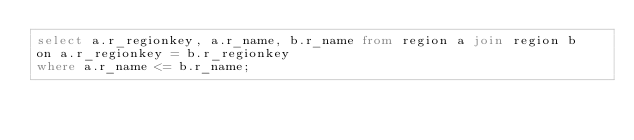<code> <loc_0><loc_0><loc_500><loc_500><_SQL_>select a.r_regionkey, a.r_name, b.r_name from region a join region b
on a.r_regionkey = b.r_regionkey
where a.r_name <= b.r_name;</code> 